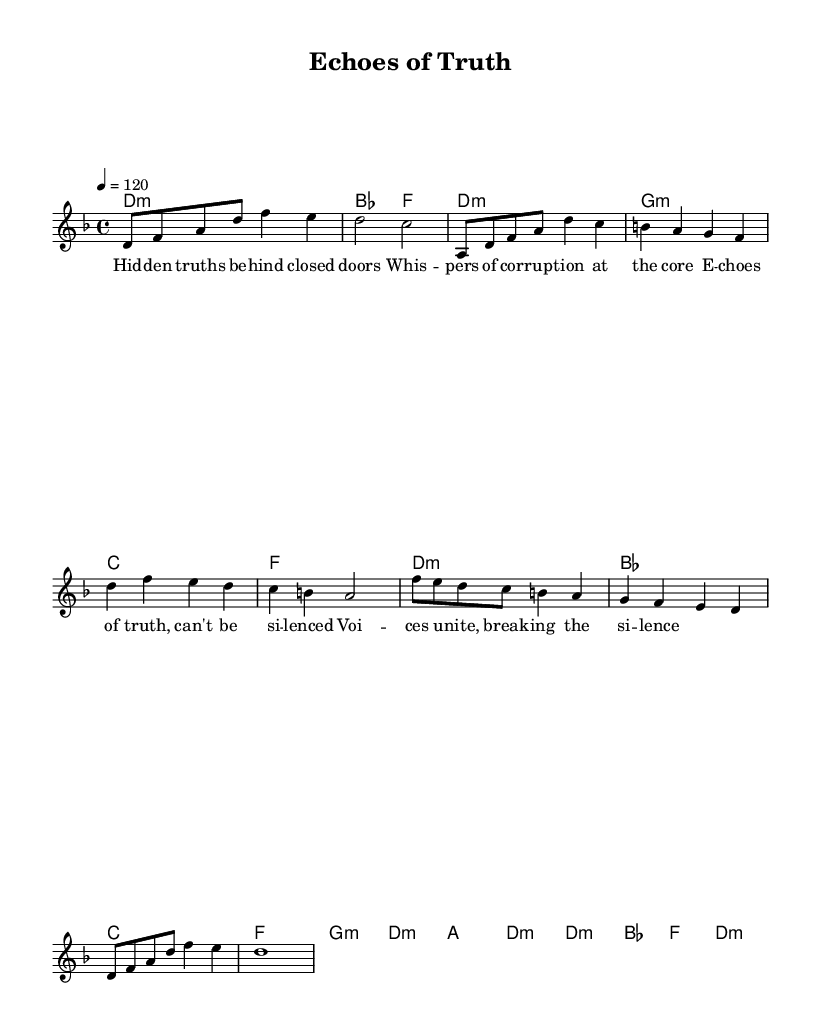What is the key signature of this music? The key signature is indicated after the clef at the beginning of the score. In this case, there is a flat next to the note lines, signifying a B flat. Therefore, the key is D minor, which has one flat (B flat).
Answer: D minor What is the time signature of this piece? The time signature appears at the beginning of the score and is represented by two numbers that indicate beats per measure. Here, it shows 4 over 4, which means there are 4 beats in each measure.
Answer: 4/4 What is the tempo marking for this composition? The tempo marking is specified as a number with the quarter note as the reference beat. In this score, it indicates that the speed of the piece is 120 beats per minute.
Answer: 120 What is the main theme of the lyrics? By examining the lyrics provided, the overall theme reflects a call for truth and transparency, focusing on corruption and the struggles for justice. The phrases highlight whispers of truth and uniting voices, indicating a narrative of resistance.
Answer: Truth and transparency How many measures are in the intro section? The intro section is delineated at the beginning of the score before the first verse. By counting the distinct sets of notes and the corresponding measure lines, there are a total of 4 measures in this section.
Answer: 4 What is the chord progression used during the chorus? The chord progression can be deduced by looking at the corresponding harmony notation under the melody for the chorus section. The specific chords used are D minor, B flat, C major, and F major.
Answer: D minor, B flat, C major, F major What musical elements make this piece symphonic metal? The elements that characterize this piece as symphonic metal include orchestral arrangements indicated by the chord progression, heavy usage of harmonies, and the juxtaposition of melodic lines paired with lyrical themes focusing on strong narratives of social justice.
Answer: Orchestral arrangements and heavy harmonies 